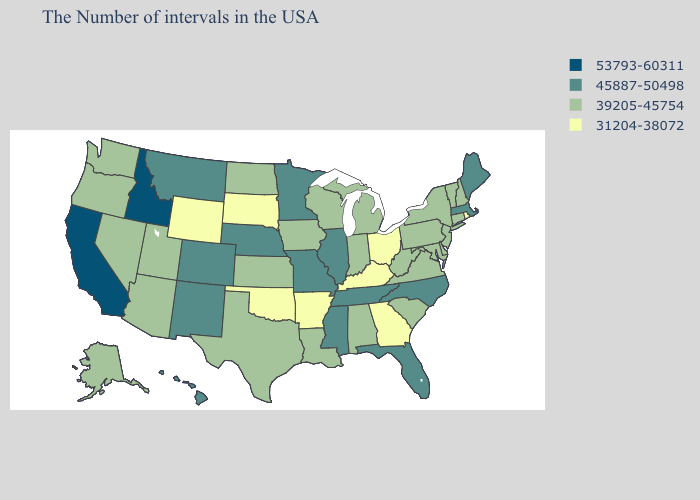What is the value of Alaska?
Keep it brief. 39205-45754. Name the states that have a value in the range 39205-45754?
Concise answer only. New Hampshire, Vermont, Connecticut, New York, New Jersey, Delaware, Maryland, Pennsylvania, Virginia, South Carolina, West Virginia, Michigan, Indiana, Alabama, Wisconsin, Louisiana, Iowa, Kansas, Texas, North Dakota, Utah, Arizona, Nevada, Washington, Oregon, Alaska. Does Utah have the highest value in the West?
Be succinct. No. What is the value of Maryland?
Write a very short answer. 39205-45754. What is the lowest value in states that border Florida?
Be succinct. 31204-38072. What is the value of Oregon?
Answer briefly. 39205-45754. Does North Dakota have a higher value than South Dakota?
Write a very short answer. Yes. Which states hav the highest value in the MidWest?
Concise answer only. Illinois, Missouri, Minnesota, Nebraska. Which states have the lowest value in the USA?
Concise answer only. Rhode Island, Ohio, Georgia, Kentucky, Arkansas, Oklahoma, South Dakota, Wyoming. What is the value of Maine?
Write a very short answer. 45887-50498. Name the states that have a value in the range 39205-45754?
Answer briefly. New Hampshire, Vermont, Connecticut, New York, New Jersey, Delaware, Maryland, Pennsylvania, Virginia, South Carolina, West Virginia, Michigan, Indiana, Alabama, Wisconsin, Louisiana, Iowa, Kansas, Texas, North Dakota, Utah, Arizona, Nevada, Washington, Oregon, Alaska. What is the value of Indiana?
Answer briefly. 39205-45754. Which states have the lowest value in the South?
Short answer required. Georgia, Kentucky, Arkansas, Oklahoma. Name the states that have a value in the range 53793-60311?
Concise answer only. Idaho, California. Which states have the highest value in the USA?
Short answer required. Idaho, California. 